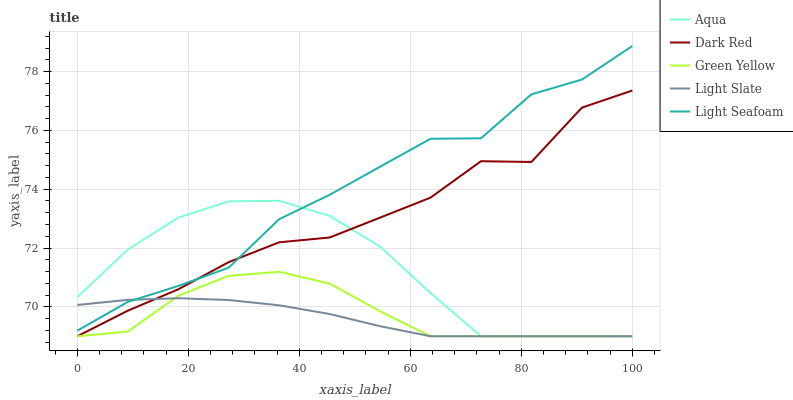Does Light Slate have the minimum area under the curve?
Answer yes or no. Yes. Does Light Seafoam have the maximum area under the curve?
Answer yes or no. Yes. Does Dark Red have the minimum area under the curve?
Answer yes or no. No. Does Dark Red have the maximum area under the curve?
Answer yes or no. No. Is Light Slate the smoothest?
Answer yes or no. Yes. Is Dark Red the roughest?
Answer yes or no. Yes. Is Green Yellow the smoothest?
Answer yes or no. No. Is Green Yellow the roughest?
Answer yes or no. No. Does Light Seafoam have the lowest value?
Answer yes or no. No. Does Light Seafoam have the highest value?
Answer yes or no. Yes. Does Dark Red have the highest value?
Answer yes or no. No. Is Green Yellow less than Light Seafoam?
Answer yes or no. Yes. Is Light Seafoam greater than Green Yellow?
Answer yes or no. Yes. Does Dark Red intersect Aqua?
Answer yes or no. Yes. Is Dark Red less than Aqua?
Answer yes or no. No. Is Dark Red greater than Aqua?
Answer yes or no. No. Does Green Yellow intersect Light Seafoam?
Answer yes or no. No. 